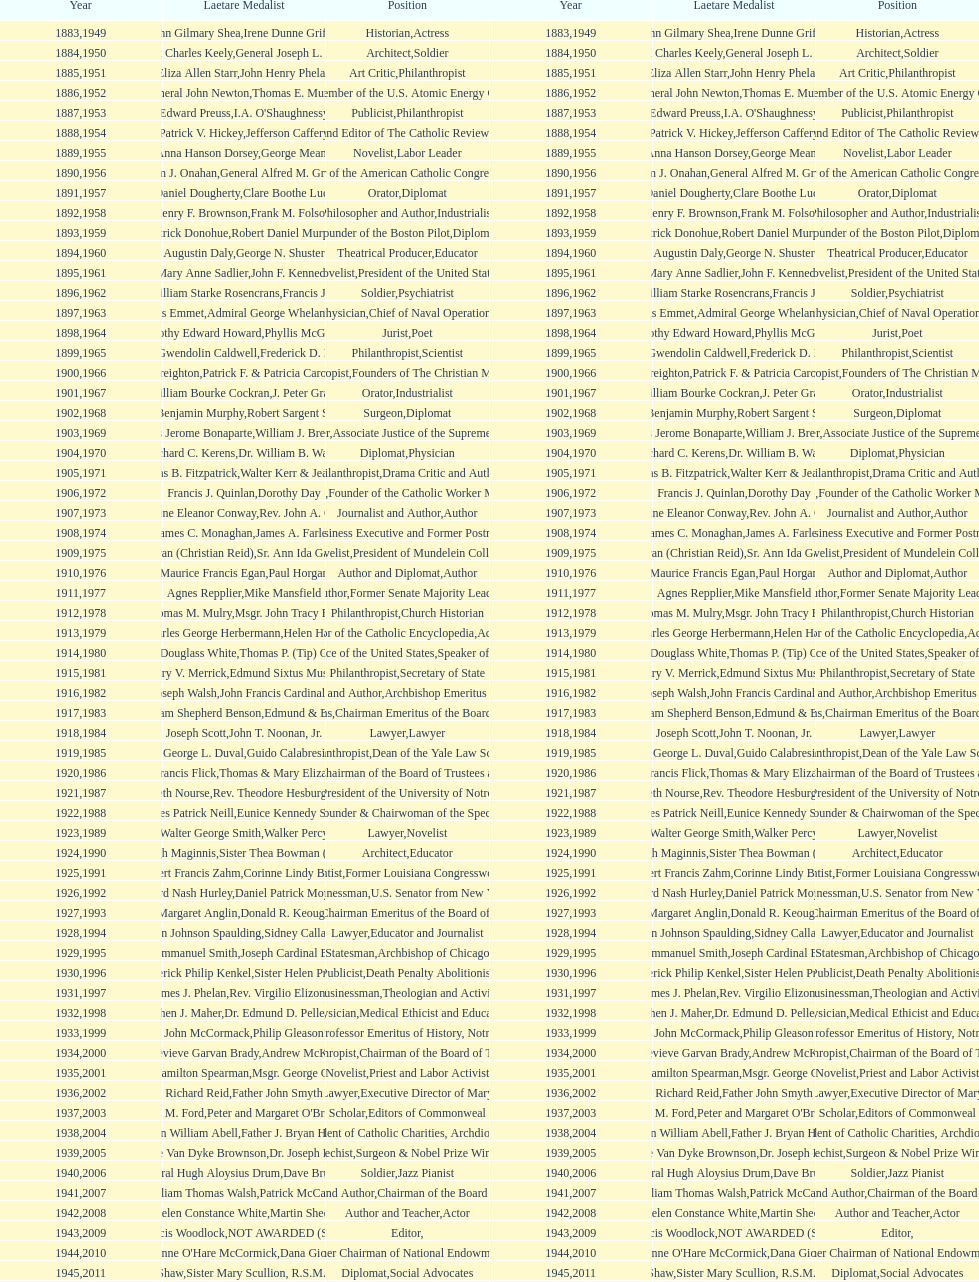Who has received this medal in addition to the nobel prize? Dr. Joseph E. Murray. 